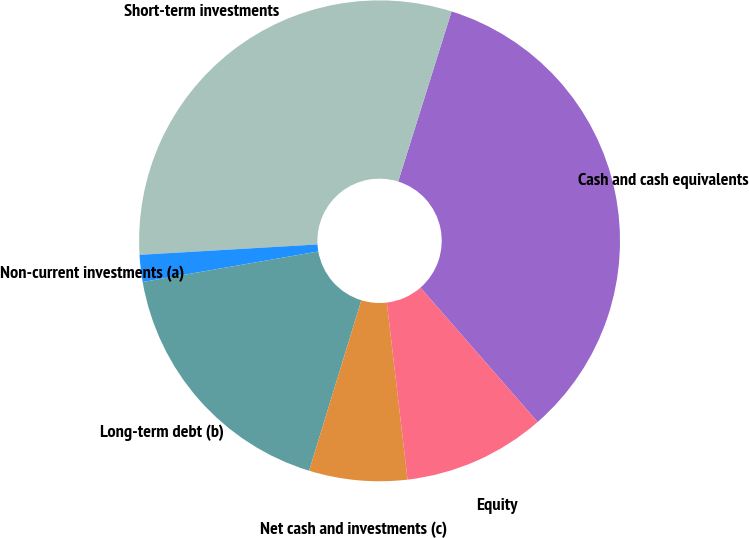Convert chart. <chart><loc_0><loc_0><loc_500><loc_500><pie_chart><fcel>Cash and cash equivalents<fcel>Short-term investments<fcel>Non-current investments (a)<fcel>Long-term debt (b)<fcel>Net cash and investments (c)<fcel>Equity<nl><fcel>33.74%<fcel>30.77%<fcel>1.81%<fcel>17.53%<fcel>6.59%<fcel>9.56%<nl></chart> 